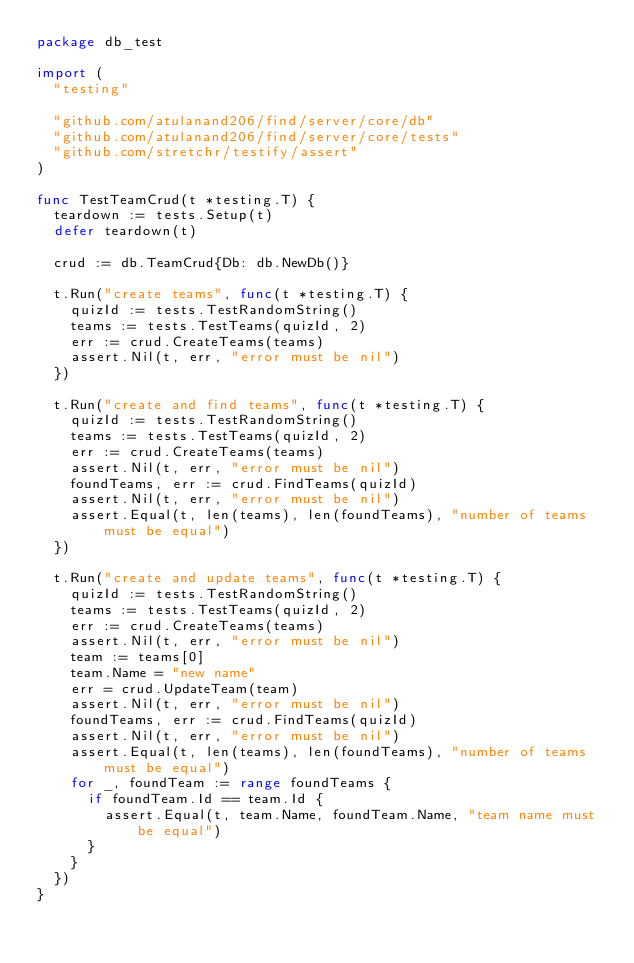Convert code to text. <code><loc_0><loc_0><loc_500><loc_500><_Go_>package db_test

import (
	"testing"

	"github.com/atulanand206/find/server/core/db"
	"github.com/atulanand206/find/server/core/tests"
	"github.com/stretchr/testify/assert"
)

func TestTeamCrud(t *testing.T) {
	teardown := tests.Setup(t)
	defer teardown(t)

	crud := db.TeamCrud{Db: db.NewDb()}

	t.Run("create teams", func(t *testing.T) {
		quizId := tests.TestRandomString()
		teams := tests.TestTeams(quizId, 2)
		err := crud.CreateTeams(teams)
		assert.Nil(t, err, "error must be nil")
	})

	t.Run("create and find teams", func(t *testing.T) {
		quizId := tests.TestRandomString()
		teams := tests.TestTeams(quizId, 2)
		err := crud.CreateTeams(teams)
		assert.Nil(t, err, "error must be nil")
		foundTeams, err := crud.FindTeams(quizId)
		assert.Nil(t, err, "error must be nil")
		assert.Equal(t, len(teams), len(foundTeams), "number of teams must be equal")
	})

	t.Run("create and update teams", func(t *testing.T) {
		quizId := tests.TestRandomString()
		teams := tests.TestTeams(quizId, 2)
		err := crud.CreateTeams(teams)
		assert.Nil(t, err, "error must be nil")
		team := teams[0]
		team.Name = "new name"
		err = crud.UpdateTeam(team)
		assert.Nil(t, err, "error must be nil")
		foundTeams, err := crud.FindTeams(quizId)
		assert.Nil(t, err, "error must be nil")
		assert.Equal(t, len(teams), len(foundTeams), "number of teams must be equal")
		for _, foundTeam := range foundTeams {
			if foundTeam.Id == team.Id {
				assert.Equal(t, team.Name, foundTeam.Name, "team name must be equal")
			}
		}
	})
}
</code> 